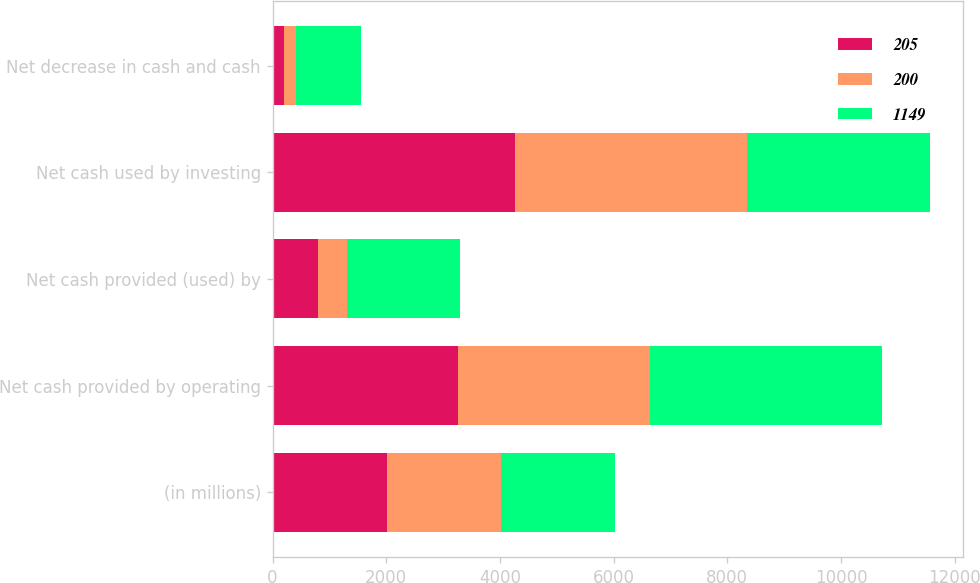Convert chart. <chart><loc_0><loc_0><loc_500><loc_500><stacked_bar_chart><ecel><fcel>(in millions)<fcel>Net cash provided by operating<fcel>Net cash provided (used) by<fcel>Net cash used by investing<fcel>Net decrease in cash and cash<nl><fcel>205<fcel>2011<fcel>3261<fcel>799<fcel>4260<fcel>200<nl><fcel>200<fcel>2010<fcel>3386<fcel>503<fcel>4094<fcel>205<nl><fcel>1149<fcel>2009<fcel>4069<fcel>1999<fcel>3219<fcel>1149<nl></chart> 